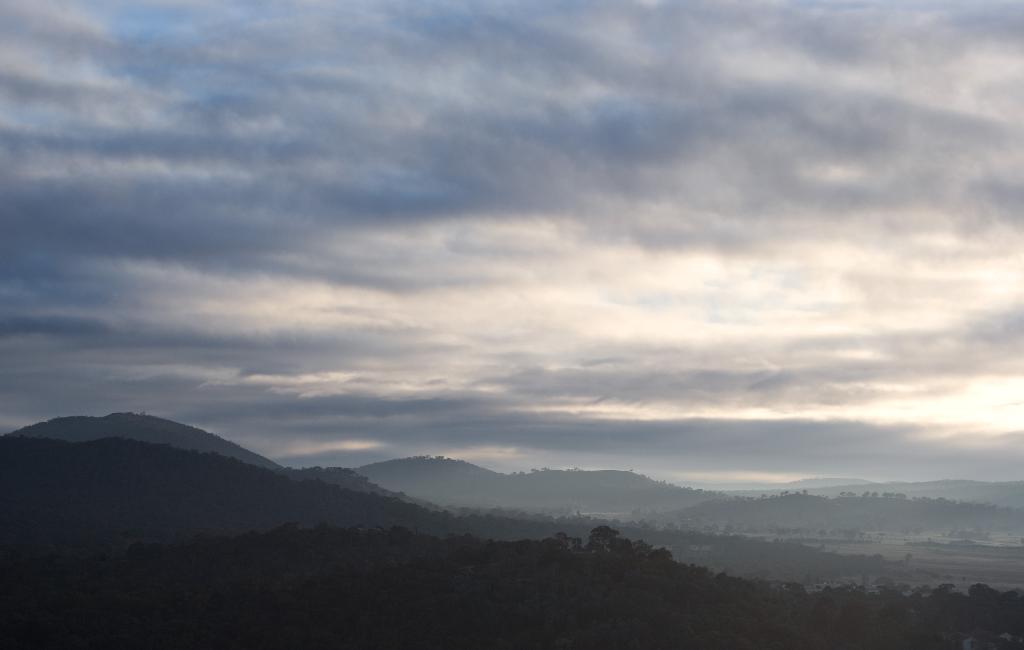In one or two sentences, can you explain what this image depicts? In the image there are plants, mountains and sky. 